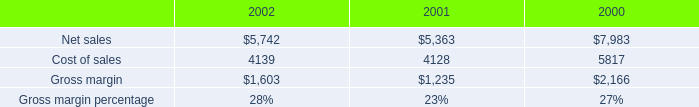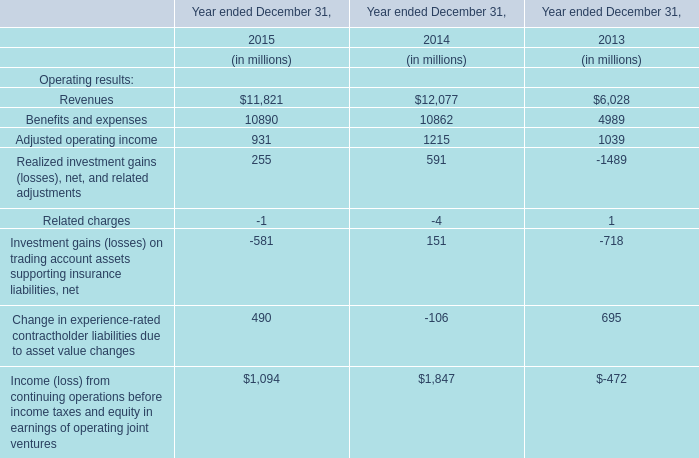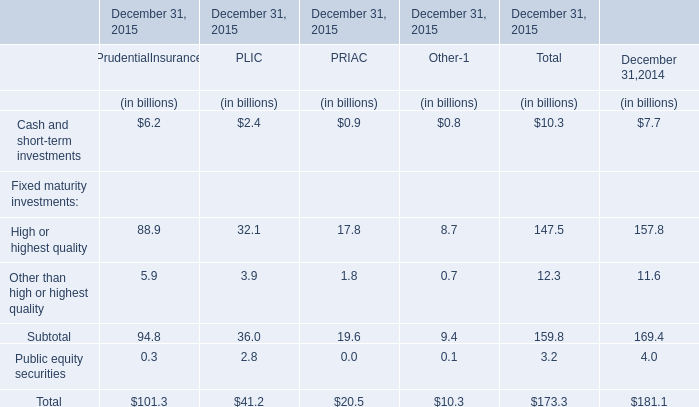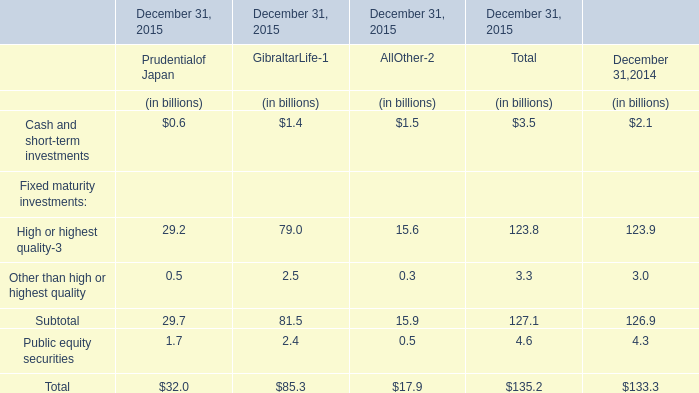What was the total amount of the High or highest quality in the years where Cash and short-term investments for Total is greater than 10? (in billion) 
Computations: (((88.9 + 32.1) + 17.8) + 8.7)
Answer: 147.5. 